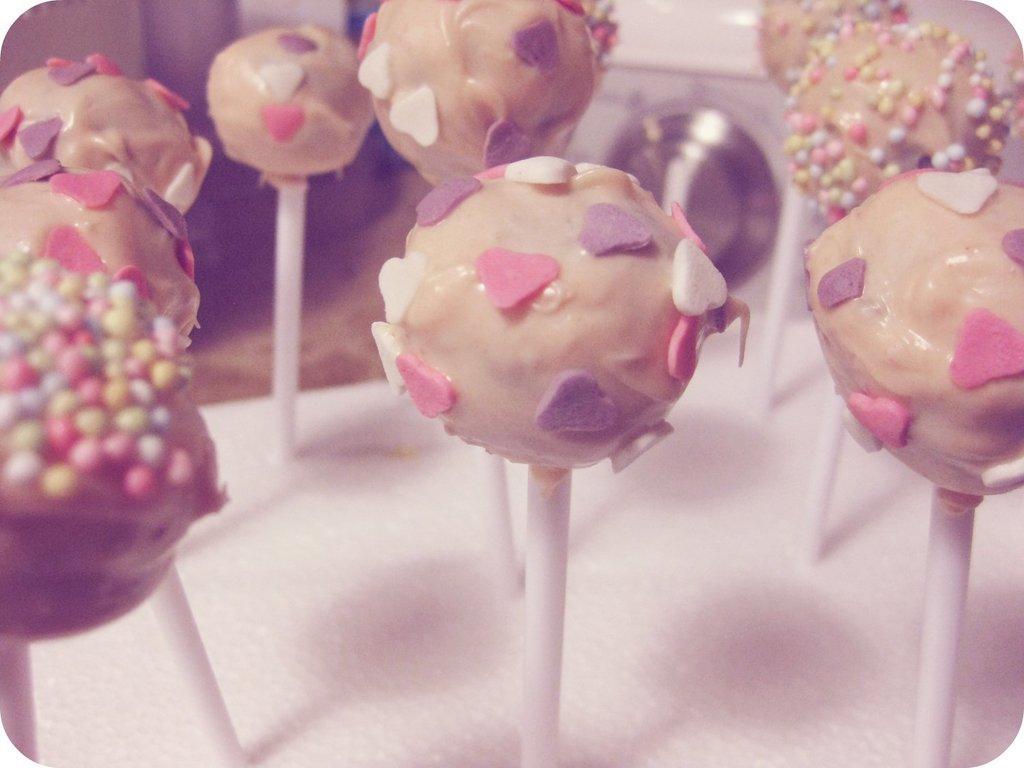How would you summarize this image in a sentence or two? In the center of the image we can see candies. In the background we can see washing machine and wall. 